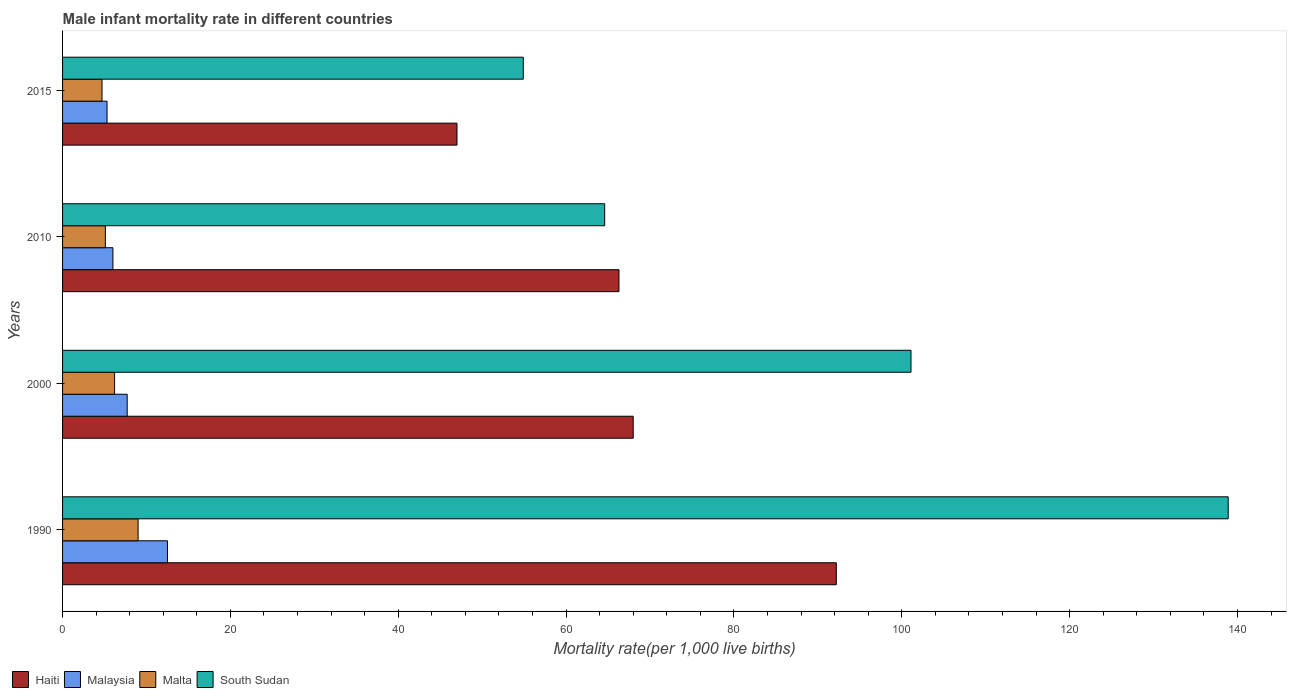How many groups of bars are there?
Give a very brief answer. 4. Are the number of bars per tick equal to the number of legend labels?
Provide a short and direct response. Yes. Are the number of bars on each tick of the Y-axis equal?
Provide a short and direct response. Yes. In how many cases, is the number of bars for a given year not equal to the number of legend labels?
Provide a succinct answer. 0. What is the male infant mortality rate in South Sudan in 2000?
Your response must be concise. 101.1. Across all years, what is the maximum male infant mortality rate in Haiti?
Your response must be concise. 92.2. Across all years, what is the minimum male infant mortality rate in South Sudan?
Give a very brief answer. 54.9. In which year was the male infant mortality rate in Malaysia maximum?
Make the answer very short. 1990. In which year was the male infant mortality rate in Malaysia minimum?
Provide a succinct answer. 2015. What is the total male infant mortality rate in Malaysia in the graph?
Your answer should be compact. 31.5. What is the difference between the male infant mortality rate in South Sudan in 2000 and that in 2010?
Make the answer very short. 36.5. What is the difference between the male infant mortality rate in South Sudan in 2010 and the male infant mortality rate in Malta in 2015?
Keep it short and to the point. 59.9. What is the average male infant mortality rate in South Sudan per year?
Ensure brevity in your answer.  89.88. In the year 2000, what is the difference between the male infant mortality rate in Malta and male infant mortality rate in Haiti?
Offer a terse response. -61.8. What is the ratio of the male infant mortality rate in South Sudan in 2000 to that in 2015?
Give a very brief answer. 1.84. Is the difference between the male infant mortality rate in Malta in 2000 and 2015 greater than the difference between the male infant mortality rate in Haiti in 2000 and 2015?
Your answer should be compact. No. What is the difference between the highest and the second highest male infant mortality rate in Malaysia?
Offer a very short reply. 4.8. What is the difference between the highest and the lowest male infant mortality rate in South Sudan?
Make the answer very short. 84. Is the sum of the male infant mortality rate in Haiti in 1990 and 2010 greater than the maximum male infant mortality rate in South Sudan across all years?
Make the answer very short. Yes. What does the 2nd bar from the top in 2015 represents?
Ensure brevity in your answer.  Malta. What does the 1st bar from the bottom in 2000 represents?
Your answer should be very brief. Haiti. Is it the case that in every year, the sum of the male infant mortality rate in South Sudan and male infant mortality rate in Malta is greater than the male infant mortality rate in Haiti?
Provide a short and direct response. Yes. How many years are there in the graph?
Your answer should be very brief. 4. What is the difference between two consecutive major ticks on the X-axis?
Your response must be concise. 20. Are the values on the major ticks of X-axis written in scientific E-notation?
Your response must be concise. No. Does the graph contain grids?
Your answer should be very brief. No. Where does the legend appear in the graph?
Offer a very short reply. Bottom left. What is the title of the graph?
Make the answer very short. Male infant mortality rate in different countries. Does "Marshall Islands" appear as one of the legend labels in the graph?
Your answer should be very brief. No. What is the label or title of the X-axis?
Offer a very short reply. Mortality rate(per 1,0 live births). What is the Mortality rate(per 1,000 live births) of Haiti in 1990?
Provide a succinct answer. 92.2. What is the Mortality rate(per 1,000 live births) in Malaysia in 1990?
Offer a very short reply. 12.5. What is the Mortality rate(per 1,000 live births) of Malta in 1990?
Offer a terse response. 9. What is the Mortality rate(per 1,000 live births) of South Sudan in 1990?
Your answer should be compact. 138.9. What is the Mortality rate(per 1,000 live births) of South Sudan in 2000?
Your response must be concise. 101.1. What is the Mortality rate(per 1,000 live births) of Haiti in 2010?
Keep it short and to the point. 66.3. What is the Mortality rate(per 1,000 live births) in South Sudan in 2010?
Your response must be concise. 64.6. What is the Mortality rate(per 1,000 live births) in Haiti in 2015?
Give a very brief answer. 47. What is the Mortality rate(per 1,000 live births) in South Sudan in 2015?
Ensure brevity in your answer.  54.9. Across all years, what is the maximum Mortality rate(per 1,000 live births) of Haiti?
Offer a terse response. 92.2. Across all years, what is the maximum Mortality rate(per 1,000 live births) of Malaysia?
Provide a short and direct response. 12.5. Across all years, what is the maximum Mortality rate(per 1,000 live births) of Malta?
Ensure brevity in your answer.  9. Across all years, what is the maximum Mortality rate(per 1,000 live births) of South Sudan?
Provide a succinct answer. 138.9. Across all years, what is the minimum Mortality rate(per 1,000 live births) of South Sudan?
Your answer should be very brief. 54.9. What is the total Mortality rate(per 1,000 live births) of Haiti in the graph?
Keep it short and to the point. 273.5. What is the total Mortality rate(per 1,000 live births) of Malaysia in the graph?
Ensure brevity in your answer.  31.5. What is the total Mortality rate(per 1,000 live births) in Malta in the graph?
Give a very brief answer. 25. What is the total Mortality rate(per 1,000 live births) in South Sudan in the graph?
Offer a very short reply. 359.5. What is the difference between the Mortality rate(per 1,000 live births) of Haiti in 1990 and that in 2000?
Your response must be concise. 24.2. What is the difference between the Mortality rate(per 1,000 live births) of Malta in 1990 and that in 2000?
Provide a short and direct response. 2.8. What is the difference between the Mortality rate(per 1,000 live births) in South Sudan in 1990 and that in 2000?
Make the answer very short. 37.8. What is the difference between the Mortality rate(per 1,000 live births) of Haiti in 1990 and that in 2010?
Provide a short and direct response. 25.9. What is the difference between the Mortality rate(per 1,000 live births) in Malta in 1990 and that in 2010?
Provide a short and direct response. 3.9. What is the difference between the Mortality rate(per 1,000 live births) of South Sudan in 1990 and that in 2010?
Keep it short and to the point. 74.3. What is the difference between the Mortality rate(per 1,000 live births) in Haiti in 1990 and that in 2015?
Make the answer very short. 45.2. What is the difference between the Mortality rate(per 1,000 live births) in Malaysia in 1990 and that in 2015?
Keep it short and to the point. 7.2. What is the difference between the Mortality rate(per 1,000 live births) in South Sudan in 1990 and that in 2015?
Provide a short and direct response. 84. What is the difference between the Mortality rate(per 1,000 live births) of South Sudan in 2000 and that in 2010?
Offer a very short reply. 36.5. What is the difference between the Mortality rate(per 1,000 live births) in South Sudan in 2000 and that in 2015?
Keep it short and to the point. 46.2. What is the difference between the Mortality rate(per 1,000 live births) of Haiti in 2010 and that in 2015?
Offer a terse response. 19.3. What is the difference between the Mortality rate(per 1,000 live births) of Malaysia in 2010 and that in 2015?
Make the answer very short. 0.7. What is the difference between the Mortality rate(per 1,000 live births) of South Sudan in 2010 and that in 2015?
Your response must be concise. 9.7. What is the difference between the Mortality rate(per 1,000 live births) in Haiti in 1990 and the Mortality rate(per 1,000 live births) in Malaysia in 2000?
Offer a very short reply. 84.5. What is the difference between the Mortality rate(per 1,000 live births) of Malaysia in 1990 and the Mortality rate(per 1,000 live births) of Malta in 2000?
Offer a terse response. 6.3. What is the difference between the Mortality rate(per 1,000 live births) of Malaysia in 1990 and the Mortality rate(per 1,000 live births) of South Sudan in 2000?
Your answer should be very brief. -88.6. What is the difference between the Mortality rate(per 1,000 live births) in Malta in 1990 and the Mortality rate(per 1,000 live births) in South Sudan in 2000?
Provide a succinct answer. -92.1. What is the difference between the Mortality rate(per 1,000 live births) in Haiti in 1990 and the Mortality rate(per 1,000 live births) in Malaysia in 2010?
Make the answer very short. 86.2. What is the difference between the Mortality rate(per 1,000 live births) of Haiti in 1990 and the Mortality rate(per 1,000 live births) of Malta in 2010?
Give a very brief answer. 87.1. What is the difference between the Mortality rate(per 1,000 live births) in Haiti in 1990 and the Mortality rate(per 1,000 live births) in South Sudan in 2010?
Your answer should be very brief. 27.6. What is the difference between the Mortality rate(per 1,000 live births) of Malaysia in 1990 and the Mortality rate(per 1,000 live births) of Malta in 2010?
Keep it short and to the point. 7.4. What is the difference between the Mortality rate(per 1,000 live births) of Malaysia in 1990 and the Mortality rate(per 1,000 live births) of South Sudan in 2010?
Your answer should be very brief. -52.1. What is the difference between the Mortality rate(per 1,000 live births) of Malta in 1990 and the Mortality rate(per 1,000 live births) of South Sudan in 2010?
Make the answer very short. -55.6. What is the difference between the Mortality rate(per 1,000 live births) of Haiti in 1990 and the Mortality rate(per 1,000 live births) of Malaysia in 2015?
Keep it short and to the point. 86.9. What is the difference between the Mortality rate(per 1,000 live births) in Haiti in 1990 and the Mortality rate(per 1,000 live births) in Malta in 2015?
Keep it short and to the point. 87.5. What is the difference between the Mortality rate(per 1,000 live births) of Haiti in 1990 and the Mortality rate(per 1,000 live births) of South Sudan in 2015?
Provide a succinct answer. 37.3. What is the difference between the Mortality rate(per 1,000 live births) of Malaysia in 1990 and the Mortality rate(per 1,000 live births) of Malta in 2015?
Your answer should be very brief. 7.8. What is the difference between the Mortality rate(per 1,000 live births) in Malaysia in 1990 and the Mortality rate(per 1,000 live births) in South Sudan in 2015?
Give a very brief answer. -42.4. What is the difference between the Mortality rate(per 1,000 live births) in Malta in 1990 and the Mortality rate(per 1,000 live births) in South Sudan in 2015?
Your answer should be very brief. -45.9. What is the difference between the Mortality rate(per 1,000 live births) in Haiti in 2000 and the Mortality rate(per 1,000 live births) in Malaysia in 2010?
Provide a succinct answer. 62. What is the difference between the Mortality rate(per 1,000 live births) in Haiti in 2000 and the Mortality rate(per 1,000 live births) in Malta in 2010?
Give a very brief answer. 62.9. What is the difference between the Mortality rate(per 1,000 live births) of Haiti in 2000 and the Mortality rate(per 1,000 live births) of South Sudan in 2010?
Make the answer very short. 3.4. What is the difference between the Mortality rate(per 1,000 live births) in Malaysia in 2000 and the Mortality rate(per 1,000 live births) in Malta in 2010?
Make the answer very short. 2.6. What is the difference between the Mortality rate(per 1,000 live births) of Malaysia in 2000 and the Mortality rate(per 1,000 live births) of South Sudan in 2010?
Offer a terse response. -56.9. What is the difference between the Mortality rate(per 1,000 live births) of Malta in 2000 and the Mortality rate(per 1,000 live births) of South Sudan in 2010?
Ensure brevity in your answer.  -58.4. What is the difference between the Mortality rate(per 1,000 live births) in Haiti in 2000 and the Mortality rate(per 1,000 live births) in Malaysia in 2015?
Provide a succinct answer. 62.7. What is the difference between the Mortality rate(per 1,000 live births) in Haiti in 2000 and the Mortality rate(per 1,000 live births) in Malta in 2015?
Provide a succinct answer. 63.3. What is the difference between the Mortality rate(per 1,000 live births) in Malaysia in 2000 and the Mortality rate(per 1,000 live births) in South Sudan in 2015?
Give a very brief answer. -47.2. What is the difference between the Mortality rate(per 1,000 live births) in Malta in 2000 and the Mortality rate(per 1,000 live births) in South Sudan in 2015?
Give a very brief answer. -48.7. What is the difference between the Mortality rate(per 1,000 live births) in Haiti in 2010 and the Mortality rate(per 1,000 live births) in Malta in 2015?
Your answer should be very brief. 61.6. What is the difference between the Mortality rate(per 1,000 live births) in Malaysia in 2010 and the Mortality rate(per 1,000 live births) in South Sudan in 2015?
Provide a succinct answer. -48.9. What is the difference between the Mortality rate(per 1,000 live births) of Malta in 2010 and the Mortality rate(per 1,000 live births) of South Sudan in 2015?
Keep it short and to the point. -49.8. What is the average Mortality rate(per 1,000 live births) of Haiti per year?
Your answer should be compact. 68.38. What is the average Mortality rate(per 1,000 live births) of Malaysia per year?
Provide a short and direct response. 7.88. What is the average Mortality rate(per 1,000 live births) of Malta per year?
Your answer should be very brief. 6.25. What is the average Mortality rate(per 1,000 live births) in South Sudan per year?
Ensure brevity in your answer.  89.88. In the year 1990, what is the difference between the Mortality rate(per 1,000 live births) in Haiti and Mortality rate(per 1,000 live births) in Malaysia?
Keep it short and to the point. 79.7. In the year 1990, what is the difference between the Mortality rate(per 1,000 live births) of Haiti and Mortality rate(per 1,000 live births) of Malta?
Provide a succinct answer. 83.2. In the year 1990, what is the difference between the Mortality rate(per 1,000 live births) in Haiti and Mortality rate(per 1,000 live births) in South Sudan?
Provide a short and direct response. -46.7. In the year 1990, what is the difference between the Mortality rate(per 1,000 live births) of Malaysia and Mortality rate(per 1,000 live births) of South Sudan?
Offer a very short reply. -126.4. In the year 1990, what is the difference between the Mortality rate(per 1,000 live births) of Malta and Mortality rate(per 1,000 live births) of South Sudan?
Ensure brevity in your answer.  -129.9. In the year 2000, what is the difference between the Mortality rate(per 1,000 live births) in Haiti and Mortality rate(per 1,000 live births) in Malaysia?
Make the answer very short. 60.3. In the year 2000, what is the difference between the Mortality rate(per 1,000 live births) in Haiti and Mortality rate(per 1,000 live births) in Malta?
Your answer should be compact. 61.8. In the year 2000, what is the difference between the Mortality rate(per 1,000 live births) in Haiti and Mortality rate(per 1,000 live births) in South Sudan?
Your response must be concise. -33.1. In the year 2000, what is the difference between the Mortality rate(per 1,000 live births) in Malaysia and Mortality rate(per 1,000 live births) in South Sudan?
Provide a short and direct response. -93.4. In the year 2000, what is the difference between the Mortality rate(per 1,000 live births) of Malta and Mortality rate(per 1,000 live births) of South Sudan?
Your response must be concise. -94.9. In the year 2010, what is the difference between the Mortality rate(per 1,000 live births) in Haiti and Mortality rate(per 1,000 live births) in Malaysia?
Your response must be concise. 60.3. In the year 2010, what is the difference between the Mortality rate(per 1,000 live births) in Haiti and Mortality rate(per 1,000 live births) in Malta?
Ensure brevity in your answer.  61.2. In the year 2010, what is the difference between the Mortality rate(per 1,000 live births) of Haiti and Mortality rate(per 1,000 live births) of South Sudan?
Make the answer very short. 1.7. In the year 2010, what is the difference between the Mortality rate(per 1,000 live births) of Malaysia and Mortality rate(per 1,000 live births) of South Sudan?
Your answer should be very brief. -58.6. In the year 2010, what is the difference between the Mortality rate(per 1,000 live births) in Malta and Mortality rate(per 1,000 live births) in South Sudan?
Offer a very short reply. -59.5. In the year 2015, what is the difference between the Mortality rate(per 1,000 live births) in Haiti and Mortality rate(per 1,000 live births) in Malaysia?
Your response must be concise. 41.7. In the year 2015, what is the difference between the Mortality rate(per 1,000 live births) in Haiti and Mortality rate(per 1,000 live births) in Malta?
Give a very brief answer. 42.3. In the year 2015, what is the difference between the Mortality rate(per 1,000 live births) in Haiti and Mortality rate(per 1,000 live births) in South Sudan?
Make the answer very short. -7.9. In the year 2015, what is the difference between the Mortality rate(per 1,000 live births) in Malaysia and Mortality rate(per 1,000 live births) in South Sudan?
Your answer should be compact. -49.6. In the year 2015, what is the difference between the Mortality rate(per 1,000 live births) in Malta and Mortality rate(per 1,000 live births) in South Sudan?
Offer a terse response. -50.2. What is the ratio of the Mortality rate(per 1,000 live births) in Haiti in 1990 to that in 2000?
Provide a succinct answer. 1.36. What is the ratio of the Mortality rate(per 1,000 live births) of Malaysia in 1990 to that in 2000?
Make the answer very short. 1.62. What is the ratio of the Mortality rate(per 1,000 live births) of Malta in 1990 to that in 2000?
Keep it short and to the point. 1.45. What is the ratio of the Mortality rate(per 1,000 live births) in South Sudan in 1990 to that in 2000?
Ensure brevity in your answer.  1.37. What is the ratio of the Mortality rate(per 1,000 live births) in Haiti in 1990 to that in 2010?
Give a very brief answer. 1.39. What is the ratio of the Mortality rate(per 1,000 live births) of Malaysia in 1990 to that in 2010?
Your answer should be compact. 2.08. What is the ratio of the Mortality rate(per 1,000 live births) in Malta in 1990 to that in 2010?
Your response must be concise. 1.76. What is the ratio of the Mortality rate(per 1,000 live births) of South Sudan in 1990 to that in 2010?
Your answer should be very brief. 2.15. What is the ratio of the Mortality rate(per 1,000 live births) in Haiti in 1990 to that in 2015?
Ensure brevity in your answer.  1.96. What is the ratio of the Mortality rate(per 1,000 live births) of Malaysia in 1990 to that in 2015?
Make the answer very short. 2.36. What is the ratio of the Mortality rate(per 1,000 live births) in Malta in 1990 to that in 2015?
Your answer should be very brief. 1.91. What is the ratio of the Mortality rate(per 1,000 live births) in South Sudan in 1990 to that in 2015?
Your answer should be very brief. 2.53. What is the ratio of the Mortality rate(per 1,000 live births) of Haiti in 2000 to that in 2010?
Provide a short and direct response. 1.03. What is the ratio of the Mortality rate(per 1,000 live births) in Malaysia in 2000 to that in 2010?
Make the answer very short. 1.28. What is the ratio of the Mortality rate(per 1,000 live births) of Malta in 2000 to that in 2010?
Offer a very short reply. 1.22. What is the ratio of the Mortality rate(per 1,000 live births) in South Sudan in 2000 to that in 2010?
Provide a succinct answer. 1.56. What is the ratio of the Mortality rate(per 1,000 live births) in Haiti in 2000 to that in 2015?
Your response must be concise. 1.45. What is the ratio of the Mortality rate(per 1,000 live births) of Malaysia in 2000 to that in 2015?
Give a very brief answer. 1.45. What is the ratio of the Mortality rate(per 1,000 live births) of Malta in 2000 to that in 2015?
Offer a very short reply. 1.32. What is the ratio of the Mortality rate(per 1,000 live births) in South Sudan in 2000 to that in 2015?
Offer a very short reply. 1.84. What is the ratio of the Mortality rate(per 1,000 live births) in Haiti in 2010 to that in 2015?
Your answer should be compact. 1.41. What is the ratio of the Mortality rate(per 1,000 live births) of Malaysia in 2010 to that in 2015?
Provide a succinct answer. 1.13. What is the ratio of the Mortality rate(per 1,000 live births) of Malta in 2010 to that in 2015?
Offer a terse response. 1.09. What is the ratio of the Mortality rate(per 1,000 live births) of South Sudan in 2010 to that in 2015?
Ensure brevity in your answer.  1.18. What is the difference between the highest and the second highest Mortality rate(per 1,000 live births) of Haiti?
Offer a terse response. 24.2. What is the difference between the highest and the second highest Mortality rate(per 1,000 live births) of Malaysia?
Keep it short and to the point. 4.8. What is the difference between the highest and the second highest Mortality rate(per 1,000 live births) of South Sudan?
Give a very brief answer. 37.8. What is the difference between the highest and the lowest Mortality rate(per 1,000 live births) in Haiti?
Your answer should be very brief. 45.2. What is the difference between the highest and the lowest Mortality rate(per 1,000 live births) in Malaysia?
Your answer should be compact. 7.2. 